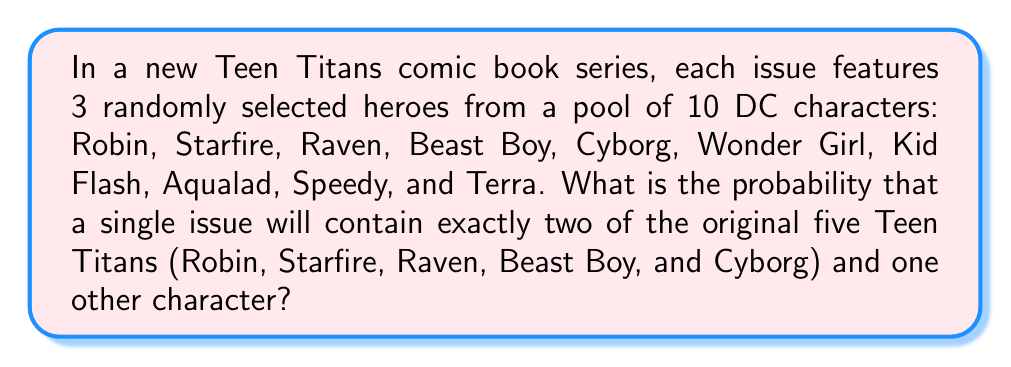Can you answer this question? Let's approach this step-by-step:

1) First, we need to calculate the total number of ways to select 3 heroes from 10 characters. This can be done using the combination formula:

   $$\binom{10}{3} = \frac{10!}{3!(10-3)!} = \frac{10!}{3!7!} = 120$$

2) Now, we need to calculate the number of favorable outcomes. We can break this down into two steps:
   a) Choose 2 from the 5 original Teen Titans
   b) Choose 1 from the other 5 characters

3) For step a, we use the combination formula again:

   $$\binom{5}{2} = \frac{5!}{2!(5-2)!} = \frac{5!}{2!3!} = 10$$

4) For step b, we simply have 5 choices, as we're selecting 1 from 5:

   $$\binom{5}{1} = 5$$

5) The total number of favorable outcomes is the product of these two:

   $$10 * 5 = 50$$

6) The probability is then the number of favorable outcomes divided by the total number of possible outcomes:

   $$P(\text{2 original Titans and 1 other}) = \frac{50}{120} = \frac{5}{12} \approx 0.4167$$
Answer: $\frac{5}{12}$ or approximately 0.4167 